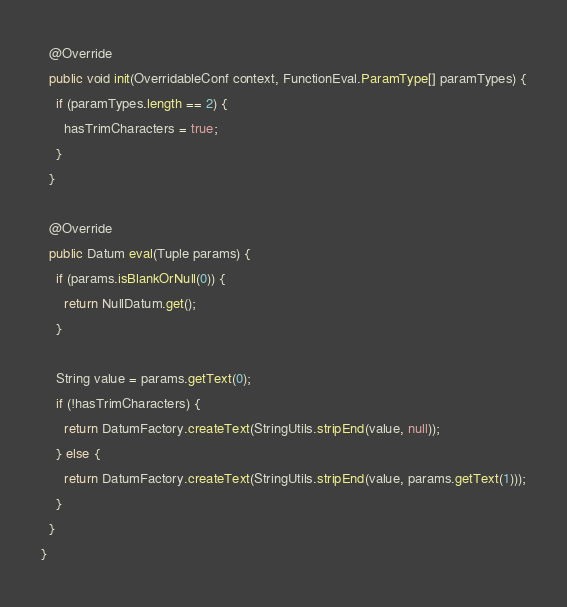<code> <loc_0><loc_0><loc_500><loc_500><_Java_>  @Override
  public void init(OverridableConf context, FunctionEval.ParamType[] paramTypes) {
    if (paramTypes.length == 2) {
      hasTrimCharacters = true;
    }
  }

  @Override
  public Datum eval(Tuple params) {
    if (params.isBlankOrNull(0)) {
      return NullDatum.get();
    }

    String value = params.getText(0);
    if (!hasTrimCharacters) {
      return DatumFactory.createText(StringUtils.stripEnd(value, null));
    } else {
      return DatumFactory.createText(StringUtils.stripEnd(value, params.getText(1)));
    }
  }
}
</code> 